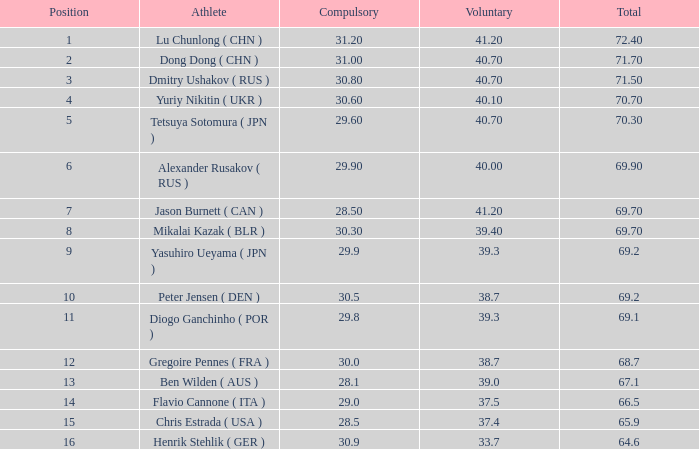What's the total compulsory when the total is more than 69.2 and the voluntary is 38.7? 0.0. 